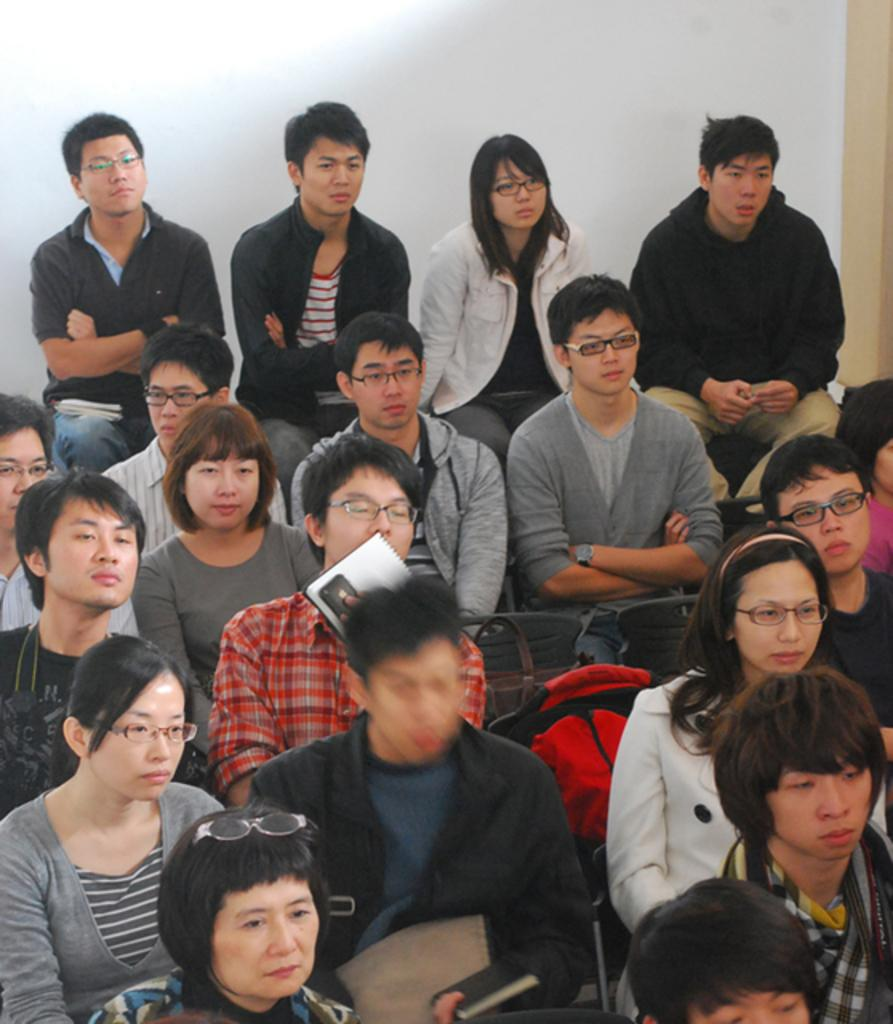What is happening in the image? There is a group of people in the image. What are the people doing in the image? The people are sitting in chairs. What objects are the people holding or using in the image? The people have books with them. What type of grain is being harvested in the image? There is no grain or harvesting activity present in the image. What theory is being discussed by the people in the image? The image does not provide any information about a theory being discussed; it only shows people sitting with books. 